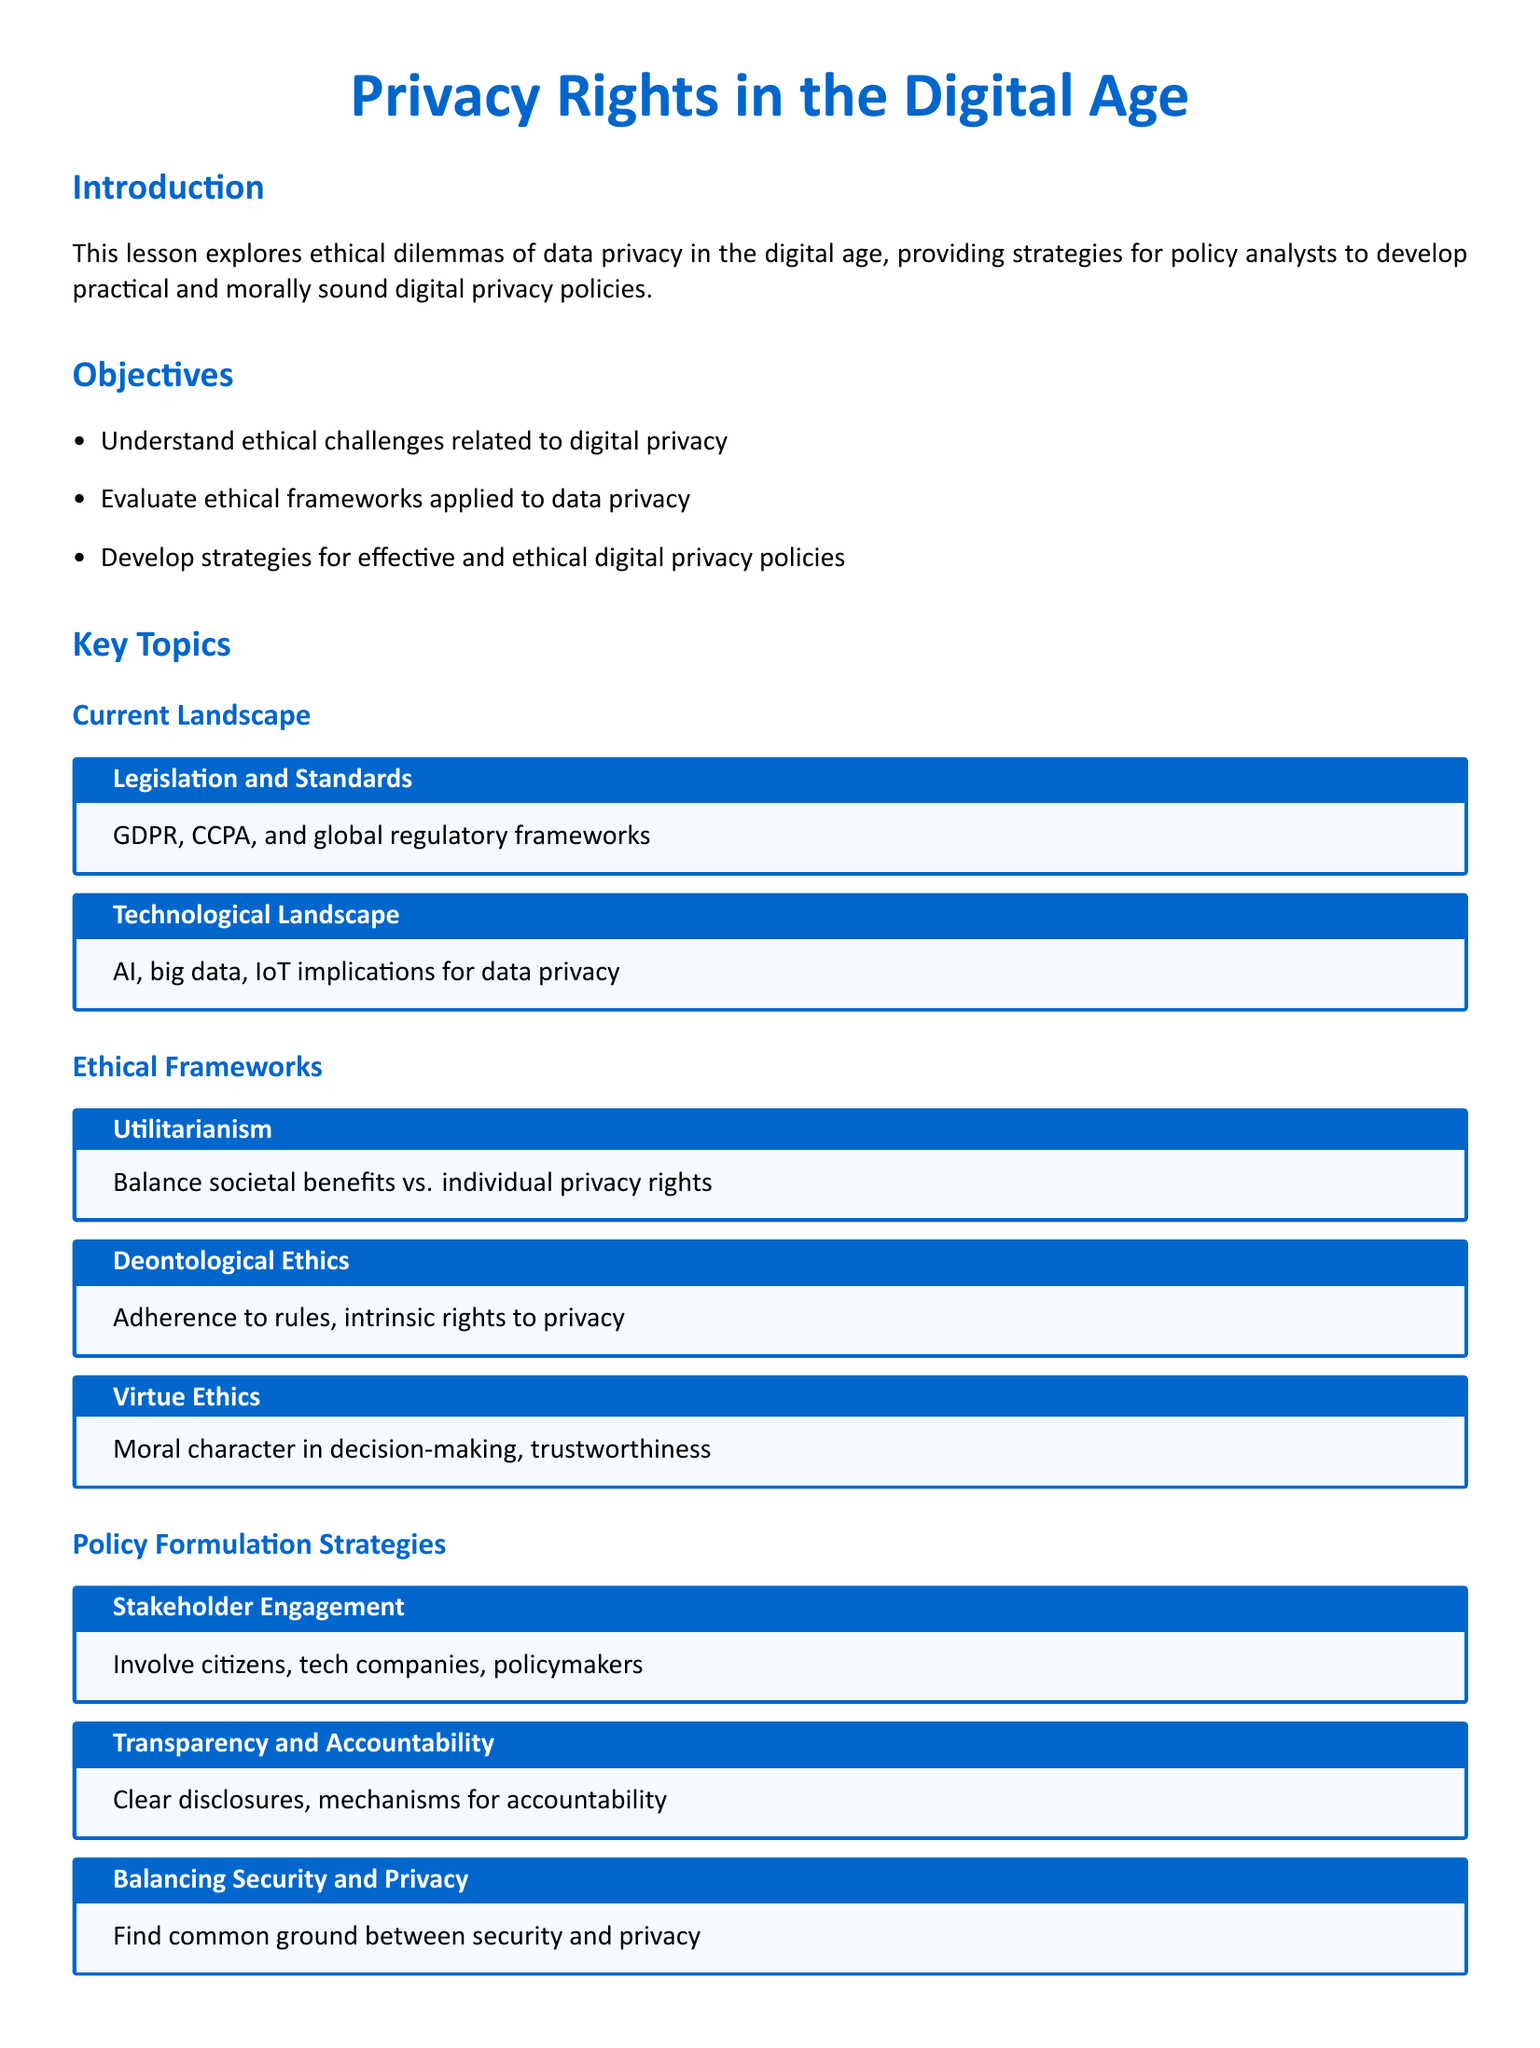what is the title of the lesson plan? The title of the lesson plan is mentioned at the beginning of the document.
Answer: Privacy Rights in the Digital Age what are the initials of the regulation mentioned in the key topics? The regulation is known by its initials, found in the Current Landscape section.
Answer: GDPR, CCPA what ethical framework focuses on moral character? This framework is part of the Ethical Frameworks section of the document.
Answer: Virtue Ethics which case study involves a scandal related to Facebook? The case study is listed under the Case Studies section of the document.
Answer: Cambridge Analytica Scandal how many objectives are outlined in the lesson plan? The number of objectives is stated in the Objectives section.
Answer: three what is one key strategy mentioned for policy formulation? This strategy is listed in the Policy Formulation Strategies section.
Answer: Stakeholder Engagement who is the author of "The Age of Surveillance Capitalism"? The author is mentioned in the Recommended Readings section of the lesson plan.
Answer: Shoshana Zuboff what does the conclusion emphasize about ethical challenges? The conclusion summarizes the key point about ethical challenges in the document.
Answer: Multifaceted approach 